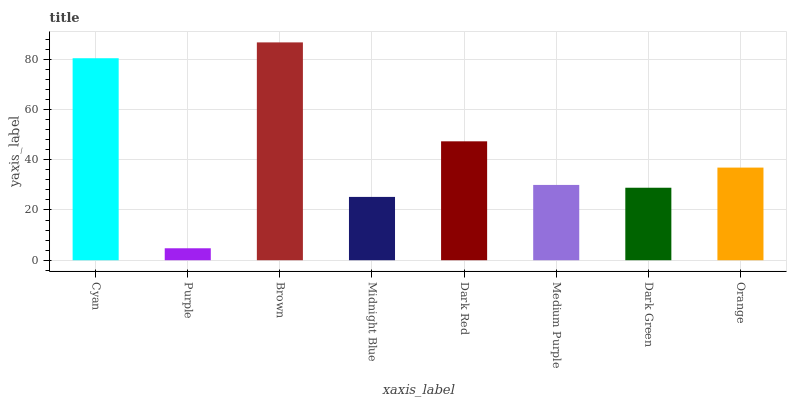Is Purple the minimum?
Answer yes or no. Yes. Is Brown the maximum?
Answer yes or no. Yes. Is Brown the minimum?
Answer yes or no. No. Is Purple the maximum?
Answer yes or no. No. Is Brown greater than Purple?
Answer yes or no. Yes. Is Purple less than Brown?
Answer yes or no. Yes. Is Purple greater than Brown?
Answer yes or no. No. Is Brown less than Purple?
Answer yes or no. No. Is Orange the high median?
Answer yes or no. Yes. Is Medium Purple the low median?
Answer yes or no. Yes. Is Medium Purple the high median?
Answer yes or no. No. Is Dark Red the low median?
Answer yes or no. No. 